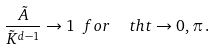Convert formula to latex. <formula><loc_0><loc_0><loc_500><loc_500>\frac { \tilde { A } } { \tilde { K } ^ { d - 1 } } \rightarrow 1 \ f o r \ \ t h t \rightarrow 0 , \pi \, .</formula> 